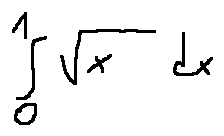<formula> <loc_0><loc_0><loc_500><loc_500>\int \lim i t s _ { 0 } ^ { 1 } \sqrt { x } d x</formula> 